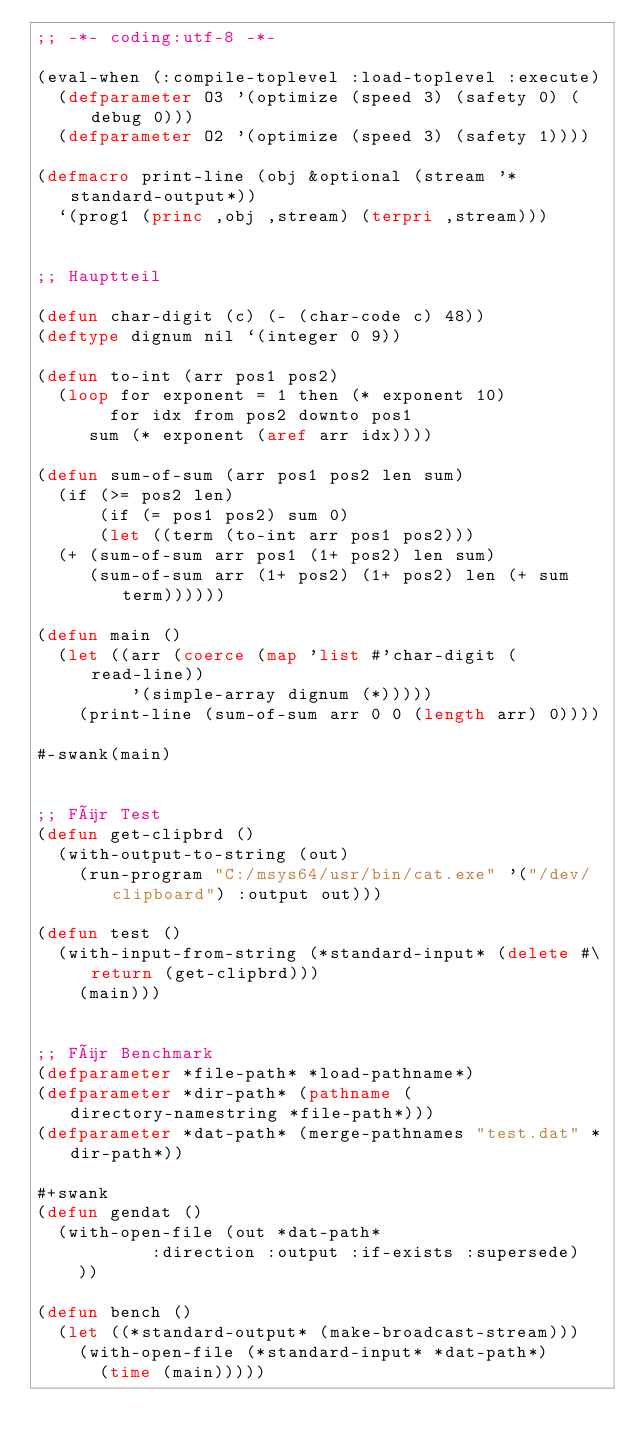Convert code to text. <code><loc_0><loc_0><loc_500><loc_500><_Lisp_>;; -*- coding:utf-8 -*-

(eval-when (:compile-toplevel :load-toplevel :execute)
  (defparameter O3 '(optimize (speed 3) (safety 0) (debug 0)))
  (defparameter O2 '(optimize (speed 3) (safety 1))))

(defmacro print-line (obj &optional (stream '*standard-output*))
  `(prog1 (princ ,obj ,stream) (terpri ,stream)))


;; Hauptteil

(defun char-digit (c) (- (char-code c) 48))
(deftype dignum nil `(integer 0 9))

(defun to-int (arr pos1 pos2)
  (loop for exponent = 1 then (* exponent 10)
       for idx from pos2 downto pos1
     sum (* exponent (aref arr idx))))

(defun sum-of-sum (arr pos1 pos2 len sum)
  (if (>= pos2 len)
      (if (= pos1 pos2) sum 0)
      (let ((term (to-int arr pos1 pos2)))
	(+ (sum-of-sum arr pos1 (1+ pos2) len sum)
	   (sum-of-sum arr (1+ pos2) (1+ pos2) len (+ sum term))))))

(defun main ()
  (let ((arr (coerce (map 'list #'char-digit (read-line))
		     '(simple-array dignum (*)))))
    (print-line (sum-of-sum arr 0 0 (length arr) 0))))

#-swank(main)


;; Für Test
(defun get-clipbrd ()
  (with-output-to-string (out)
    (run-program "C:/msys64/usr/bin/cat.exe" '("/dev/clipboard") :output out)))

(defun test ()
  (with-input-from-string (*standard-input* (delete #\return (get-clipbrd)))
    (main)))


;; Für Benchmark
(defparameter *file-path* *load-pathname*)
(defparameter *dir-path* (pathname (directory-namestring *file-path*)))
(defparameter *dat-path* (merge-pathnames "test.dat" *dir-path*))

#+swank
(defun gendat ()
  (with-open-file (out *dat-path*
		       :direction :output :if-exists :supersede)
    ))

(defun bench ()
  (let ((*standard-output* (make-broadcast-stream)))
    (with-open-file (*standard-input* *dat-path*)
      (time (main)))))
</code> 